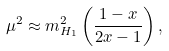Convert formula to latex. <formula><loc_0><loc_0><loc_500><loc_500>\mu ^ { 2 } \approx m _ { H _ { 1 } } ^ { 2 } \left ( \frac { 1 - x } { 2 x - 1 } \right ) ,</formula> 